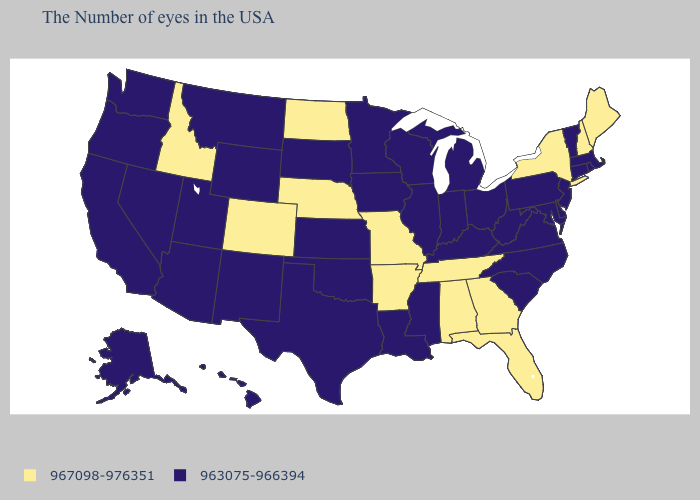What is the highest value in the West ?
Keep it brief. 967098-976351. Does Michigan have the highest value in the MidWest?
Give a very brief answer. No. Is the legend a continuous bar?
Be succinct. No. What is the value of North Dakota?
Give a very brief answer. 967098-976351. Name the states that have a value in the range 967098-976351?
Short answer required. Maine, New Hampshire, New York, Florida, Georgia, Alabama, Tennessee, Missouri, Arkansas, Nebraska, North Dakota, Colorado, Idaho. Name the states that have a value in the range 967098-976351?
Give a very brief answer. Maine, New Hampshire, New York, Florida, Georgia, Alabama, Tennessee, Missouri, Arkansas, Nebraska, North Dakota, Colorado, Idaho. Does the map have missing data?
Concise answer only. No. What is the highest value in states that border Tennessee?
Concise answer only. 967098-976351. What is the highest value in the MidWest ?
Quick response, please. 967098-976351. Does Tennessee have the highest value in the South?
Write a very short answer. Yes. What is the highest value in the USA?
Keep it brief. 967098-976351. Name the states that have a value in the range 963075-966394?
Quick response, please. Massachusetts, Rhode Island, Vermont, Connecticut, New Jersey, Delaware, Maryland, Pennsylvania, Virginia, North Carolina, South Carolina, West Virginia, Ohio, Michigan, Kentucky, Indiana, Wisconsin, Illinois, Mississippi, Louisiana, Minnesota, Iowa, Kansas, Oklahoma, Texas, South Dakota, Wyoming, New Mexico, Utah, Montana, Arizona, Nevada, California, Washington, Oregon, Alaska, Hawaii. What is the value of New York?
Quick response, please. 967098-976351. Among the states that border New Hampshire , does Vermont have the highest value?
Be succinct. No. How many symbols are there in the legend?
Short answer required. 2. 